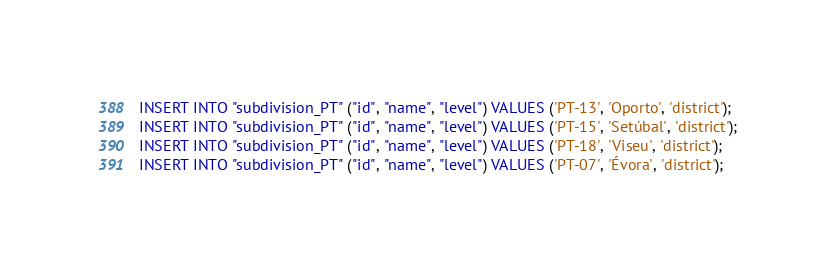Convert code to text. <code><loc_0><loc_0><loc_500><loc_500><_SQL_>INSERT INTO "subdivision_PT" ("id", "name", "level") VALUES ('PT-13', 'Oporto', 'district');
INSERT INTO "subdivision_PT" ("id", "name", "level") VALUES ('PT-15', 'Setúbal', 'district');
INSERT INTO "subdivision_PT" ("id", "name", "level") VALUES ('PT-18', 'Viseu', 'district');
INSERT INTO "subdivision_PT" ("id", "name", "level") VALUES ('PT-07', 'Évora', 'district');
</code> 